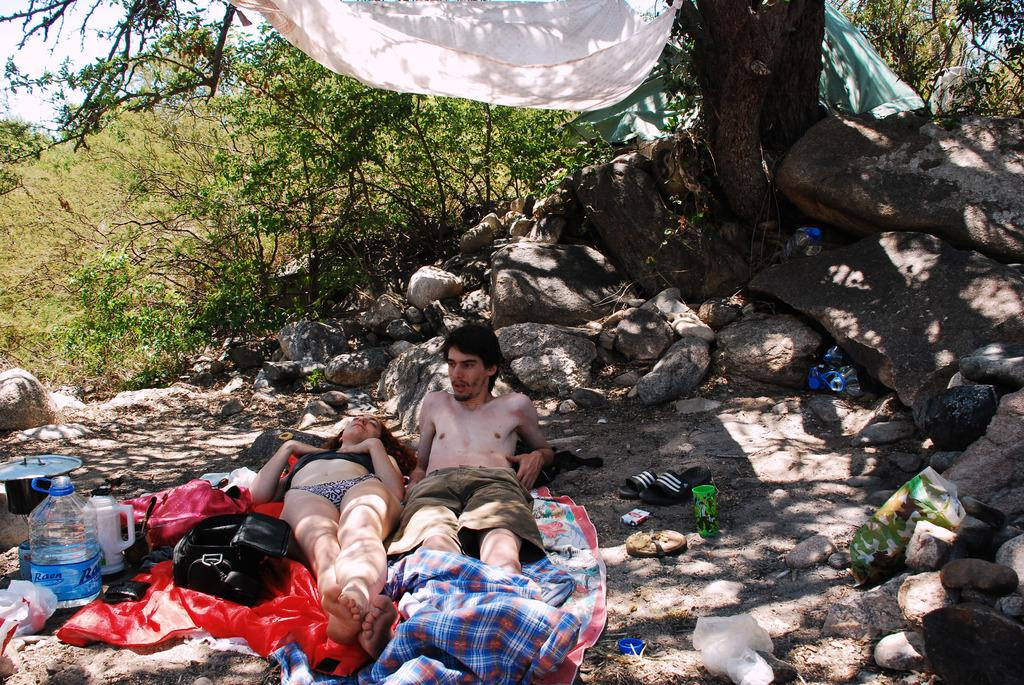How many people are in the image? There are two people in the image. What is one person doing in the image? One person is laying on a cloth. What items can be seen related to hydration in the image? There is a water bottle and a jug visible in the image. What type of footwear is present in the image? Footwear is present in the image. What objects are in the image? Covers are in the image. What can be seen in the background of the image? Trees, clothes, stones, and the sky are visible in the background of the image. What type of beef is being cooked on the potato in the image? There is no beef or potato present in the image. 